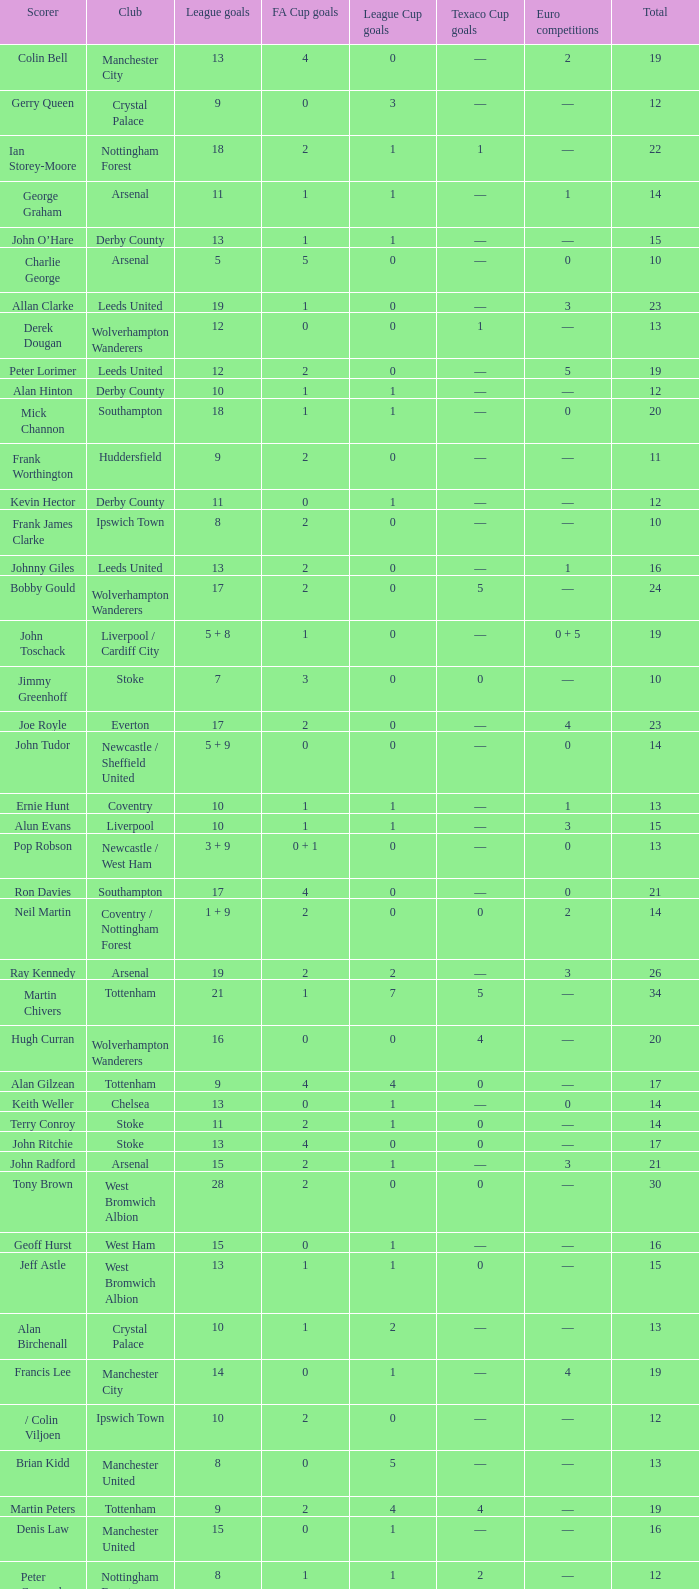What is the average Total, when FA Cup Goals is 1, when League Goals is 10, and when Club is Crystal Palace? 13.0. 